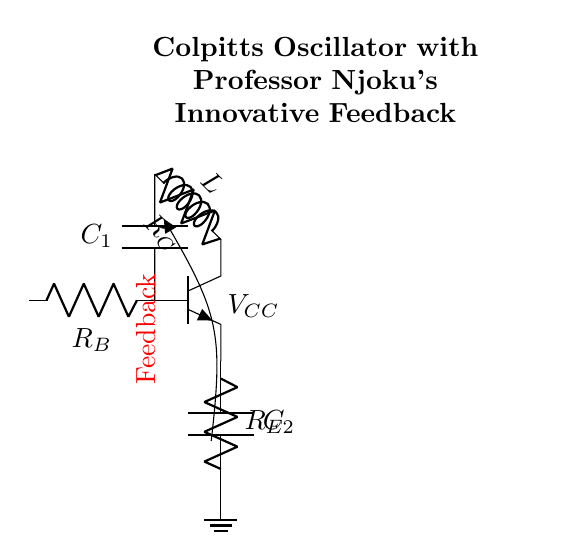What is the type of transistor used in the circuit? The circuit diagram shows an npn transistor, which is indicated by the label "npn" next to the transistor symbol.
Answer: npn What are the values of the capacitors in the circuit? The circuit diagram labels the capacitors as C1 and C2, but does not provide numeric values.
Answer: C1 and C2 What is the role of the inductor in this oscillator? The inductor, labeled L, is part of the feedback network and works with the capacitors to determine the oscillation frequency.
Answer: Determine frequency What component provides the feedback in the circuit? The feedback is indicated with a red, thick line labeled "Feedback," showing that it originates from the collector or output of the npn transistor.
Answer: Feedback Which component connects the power supply in the circuit? The circuit diagram shows a connection from the top capacitor node to the ground indicating the presence of the power supply, with the label "V_CC."
Answer: V_CC How many resistors are in the circuit and what are they labeled? The circuit has three resistors labeled R_B, R_C, and R_E, which are connected in various parts of the circuit for biasing and stability.
Answer: Three (R_B, R_C, R_E) Why is the feedback technique important in this oscillator? The feedback technique allows the circuit to sustain oscillations by reinforcing the oscillating signal, which is crucial for the operation of a Colpitts oscillator.
Answer: Sustain oscillations 